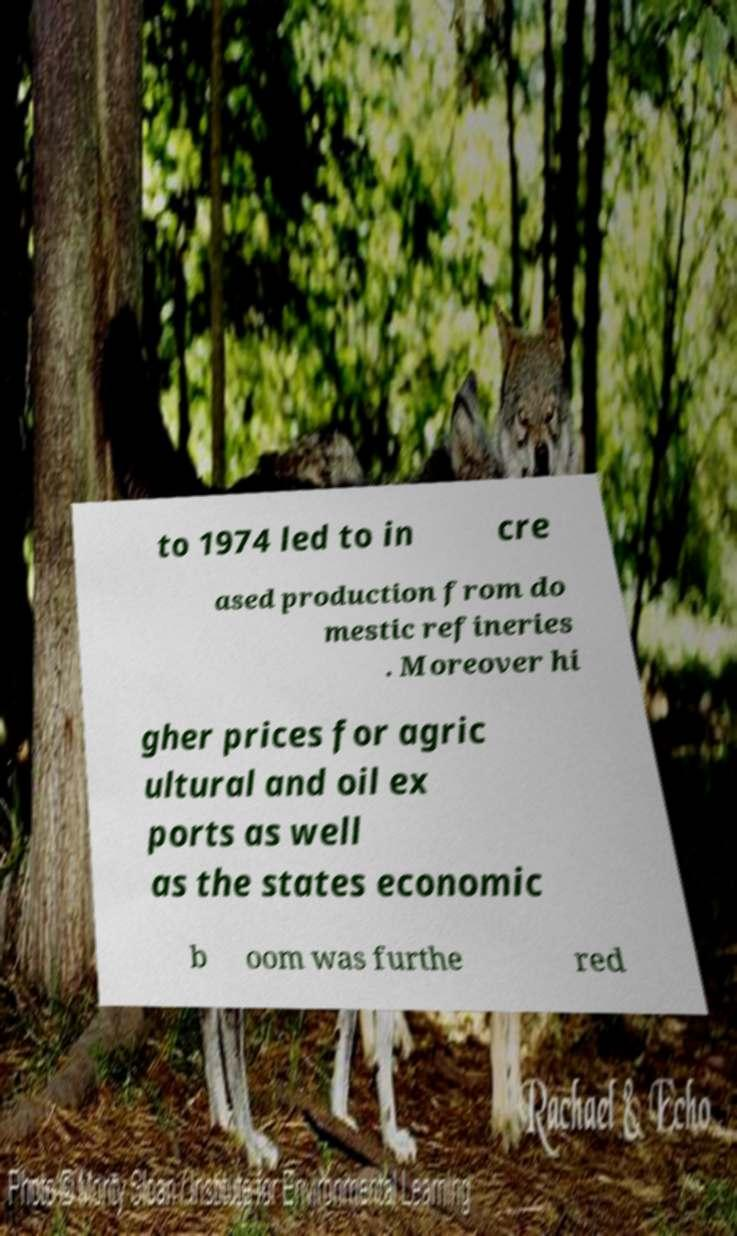Can you read and provide the text displayed in the image?This photo seems to have some interesting text. Can you extract and type it out for me? to 1974 led to in cre ased production from do mestic refineries . Moreover hi gher prices for agric ultural and oil ex ports as well as the states economic b oom was furthe red 